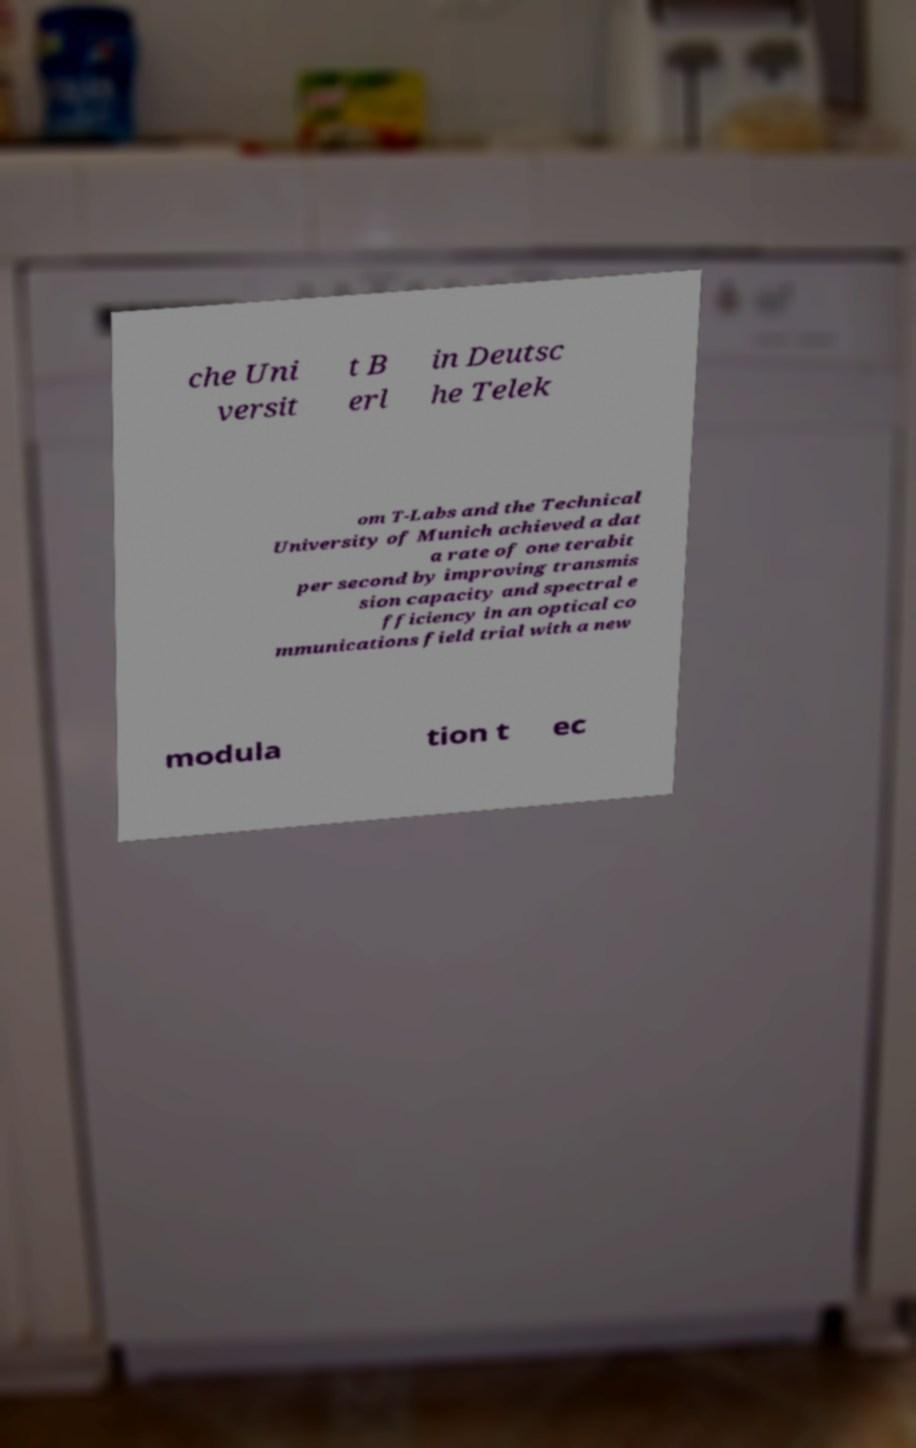Could you assist in decoding the text presented in this image and type it out clearly? che Uni versit t B erl in Deutsc he Telek om T-Labs and the Technical University of Munich achieved a dat a rate of one terabit per second by improving transmis sion capacity and spectral e fficiency in an optical co mmunications field trial with a new modula tion t ec 